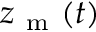Convert formula to latex. <formula><loc_0><loc_0><loc_500><loc_500>z _ { m } ( t )</formula> 